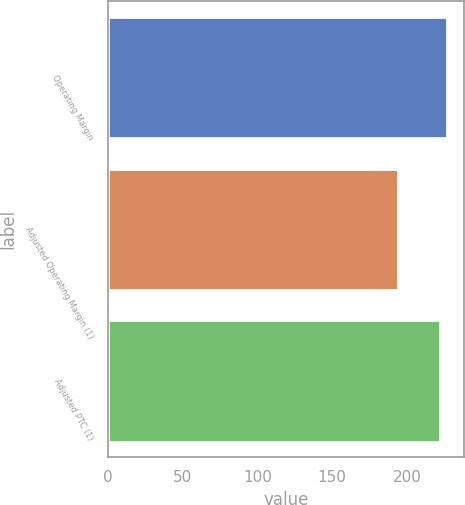Convert chart to OTSL. <chart><loc_0><loc_0><loc_500><loc_500><bar_chart><fcel>Operating Margin<fcel>Adjusted Operating Margin (1)<fcel>Adjusted PTC (1)<nl><fcel>227<fcel>194<fcel>222<nl></chart> 